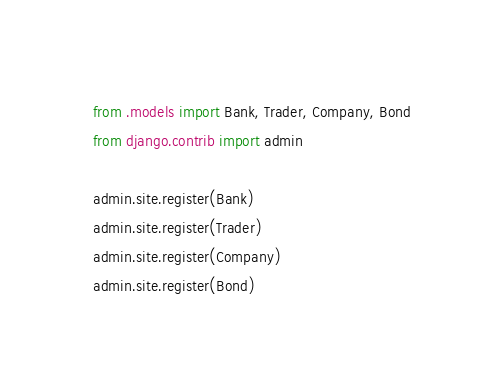Convert code to text. <code><loc_0><loc_0><loc_500><loc_500><_Python_>from .models import Bank, Trader, Company, Bond
from django.contrib import admin

admin.site.register(Bank)
admin.site.register(Trader)
admin.site.register(Company)
admin.site.register(Bond)
</code> 